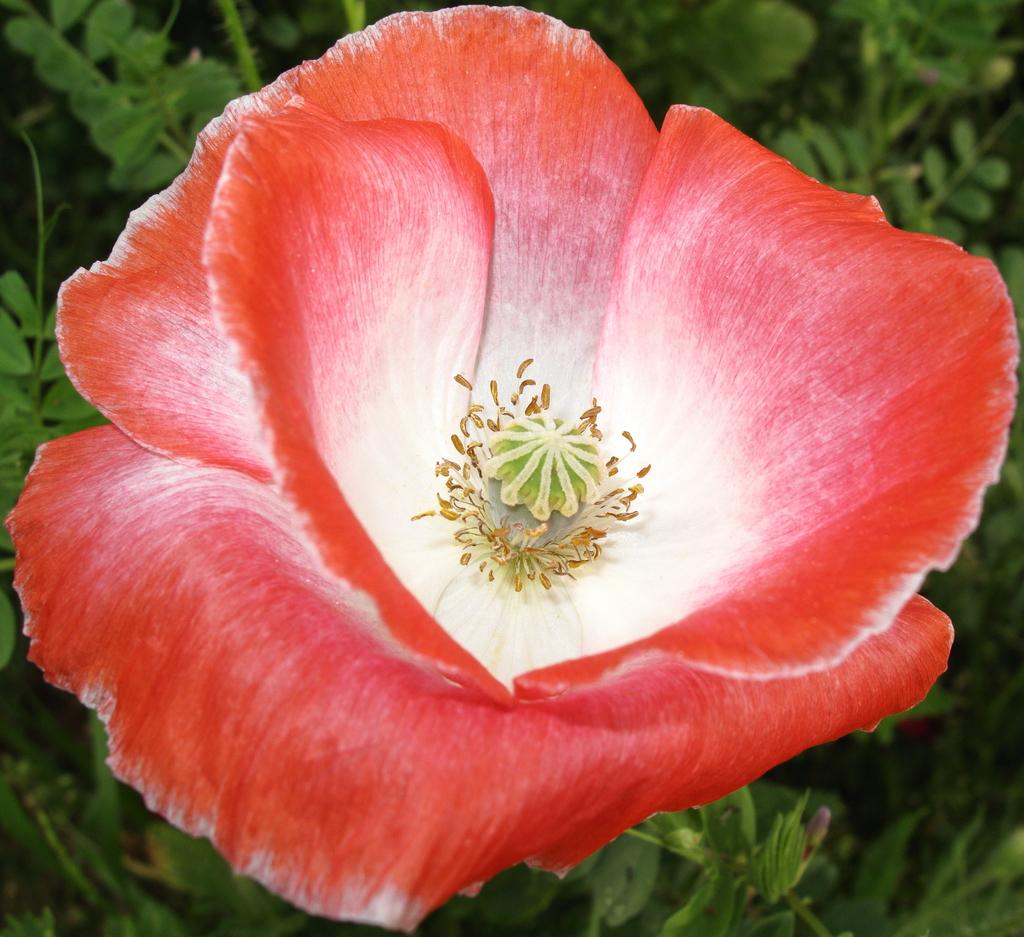What type of plant can be seen in the image? There is a flower in the image. What part of the plant is visible in the image? There are green leaves in the image. What type of religious symbol is present in the image? There is no religious symbol present in the image; it only features a flower and green leaves. 